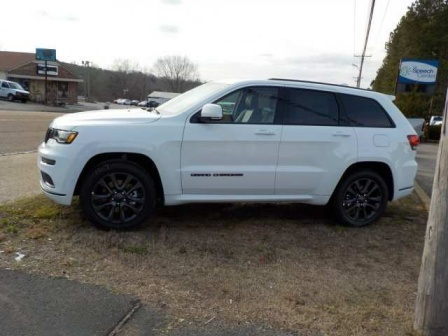Imagine if this scene was part of a movie. What genre would it be and why? This scene could belong to a mystery thriller. The solitary white Jeep Grand Cherokee parked on a desolate patch of grass evokes a sense of intrigue. The quiet and seemingly ordinary suburban backdrop contrasts sharply with the suspenseful undercurrent that something unexpected might occur. Perhaps the building in the background holds a secret, or the SUV’s driver is on a mysterious mission, making the ordinary setting a deceptive cover for the unfolding drama. 